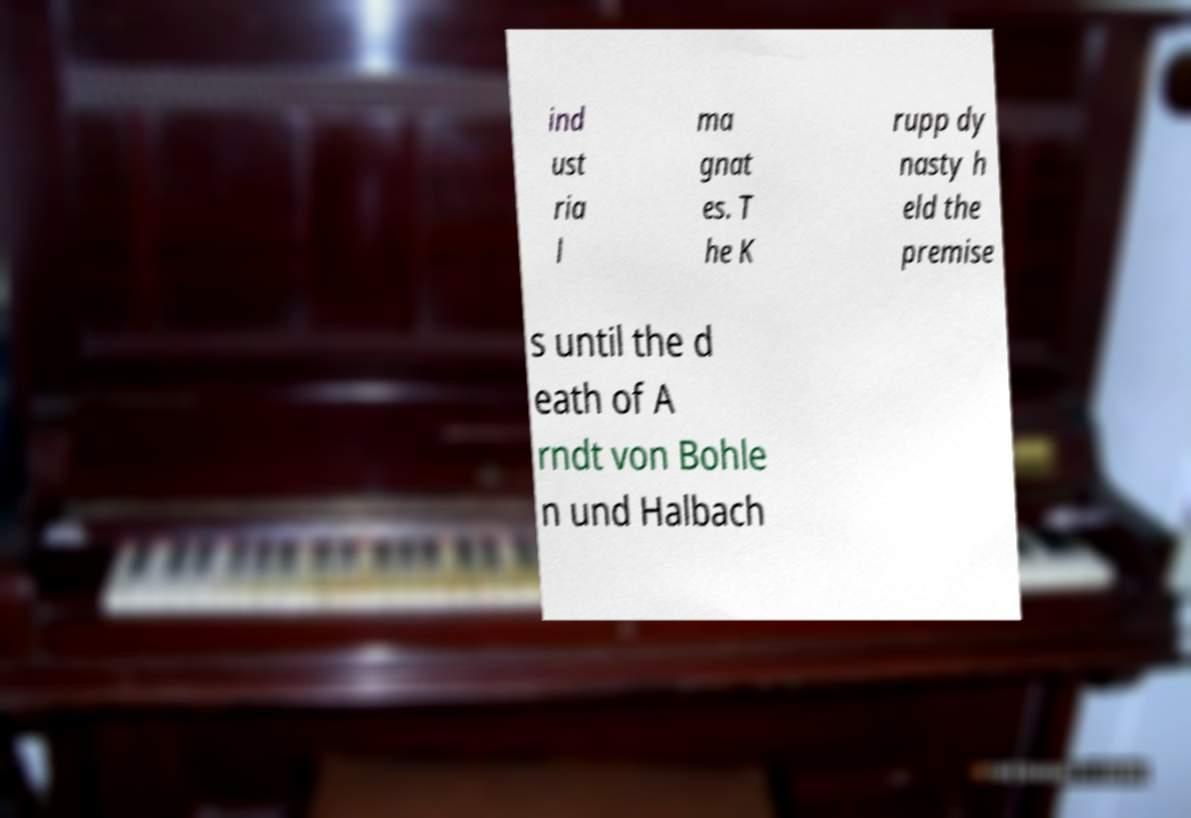I need the written content from this picture converted into text. Can you do that? ind ust ria l ma gnat es. T he K rupp dy nasty h eld the premise s until the d eath of A rndt von Bohle n und Halbach 